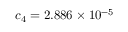<formula> <loc_0><loc_0><loc_500><loc_500>c _ { 4 } = 2 . 8 8 6 \times 1 0 ^ { - 5 }</formula> 